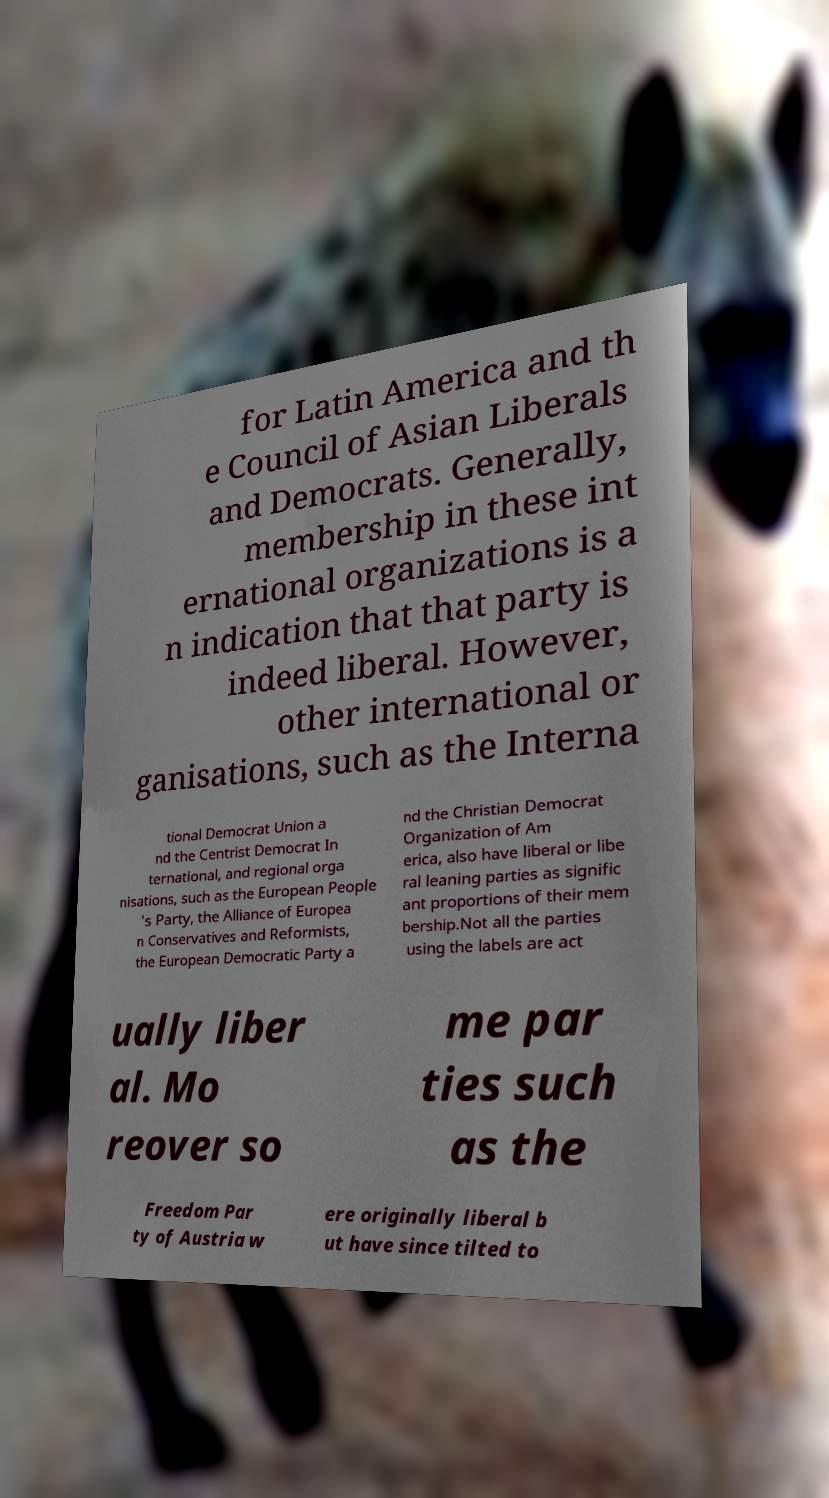What messages or text are displayed in this image? I need them in a readable, typed format. for Latin America and th e Council of Asian Liberals and Democrats. Generally, membership in these int ernational organizations is a n indication that that party is indeed liberal. However, other international or ganisations, such as the Interna tional Democrat Union a nd the Centrist Democrat In ternational, and regional orga nisations, such as the European People 's Party, the Alliance of Europea n Conservatives and Reformists, the European Democratic Party a nd the Christian Democrat Organization of Am erica, also have liberal or libe ral leaning parties as signific ant proportions of their mem bership.Not all the parties using the labels are act ually liber al. Mo reover so me par ties such as the Freedom Par ty of Austria w ere originally liberal b ut have since tilted to 